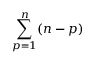<formula> <loc_0><loc_0><loc_500><loc_500>\sum _ { p = 1 } ^ { n } ( n - p )</formula> 